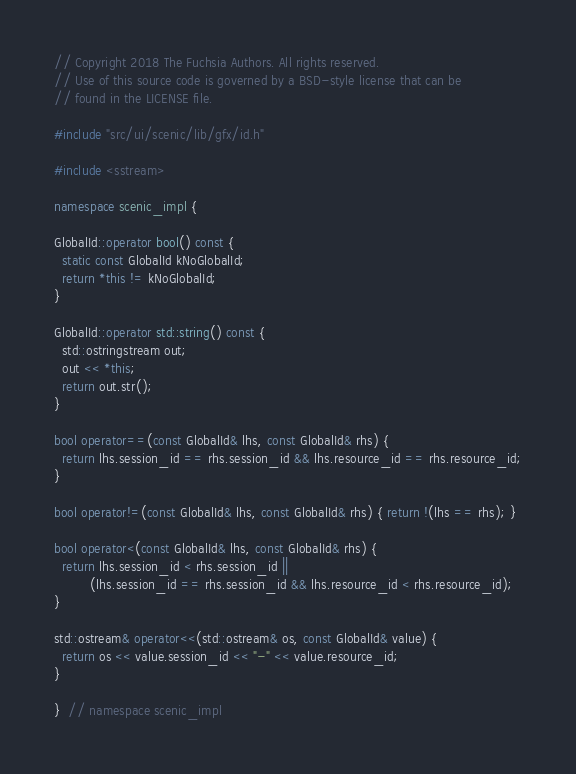<code> <loc_0><loc_0><loc_500><loc_500><_C++_>// Copyright 2018 The Fuchsia Authors. All rights reserved.
// Use of this source code is governed by a BSD-style license that can be
// found in the LICENSE file.

#include "src/ui/scenic/lib/gfx/id.h"

#include <sstream>

namespace scenic_impl {

GlobalId::operator bool() const {
  static const GlobalId kNoGlobalId;
  return *this != kNoGlobalId;
}

GlobalId::operator std::string() const {
  std::ostringstream out;
  out << *this;
  return out.str();
}

bool operator==(const GlobalId& lhs, const GlobalId& rhs) {
  return lhs.session_id == rhs.session_id && lhs.resource_id == rhs.resource_id;
}

bool operator!=(const GlobalId& lhs, const GlobalId& rhs) { return !(lhs == rhs); }

bool operator<(const GlobalId& lhs, const GlobalId& rhs) {
  return lhs.session_id < rhs.session_id ||
         (lhs.session_id == rhs.session_id && lhs.resource_id < rhs.resource_id);
}

std::ostream& operator<<(std::ostream& os, const GlobalId& value) {
  return os << value.session_id << "-" << value.resource_id;
}

}  // namespace scenic_impl
</code> 